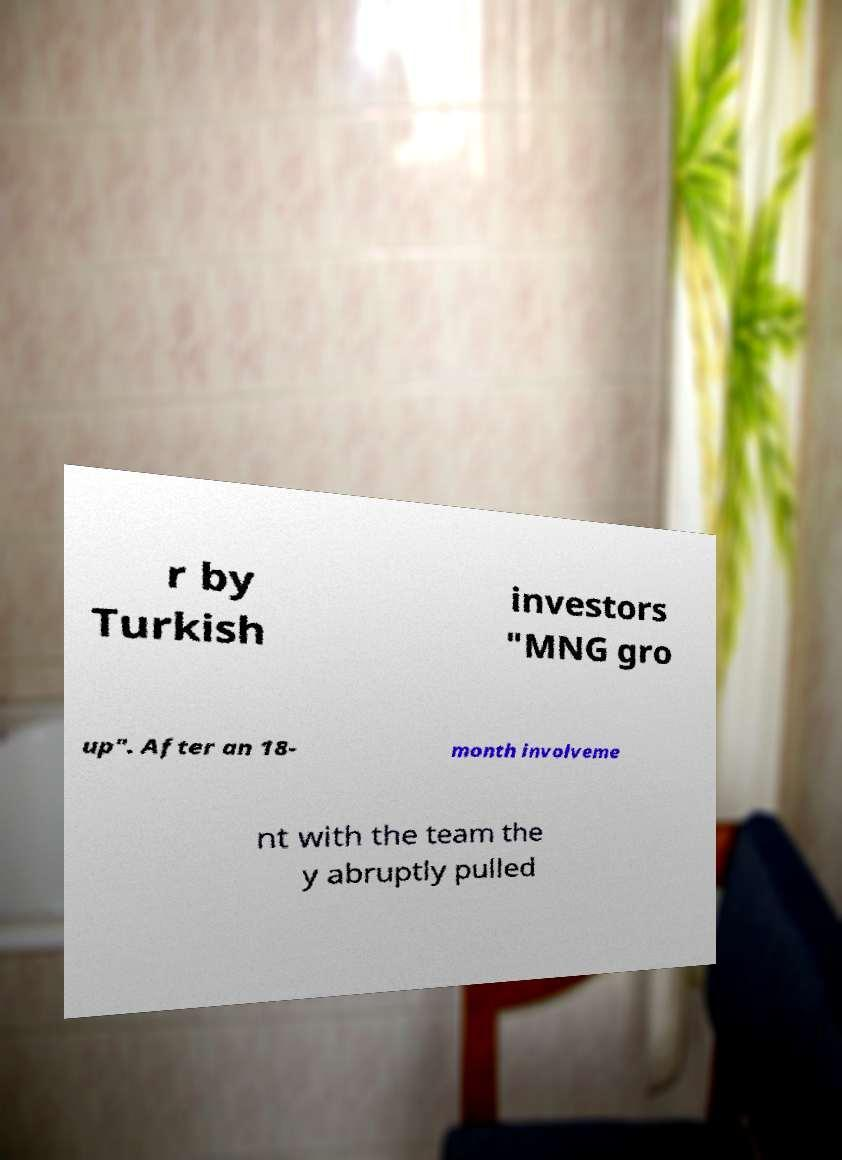For documentation purposes, I need the text within this image transcribed. Could you provide that? r by Turkish investors "MNG gro up". After an 18- month involveme nt with the team the y abruptly pulled 